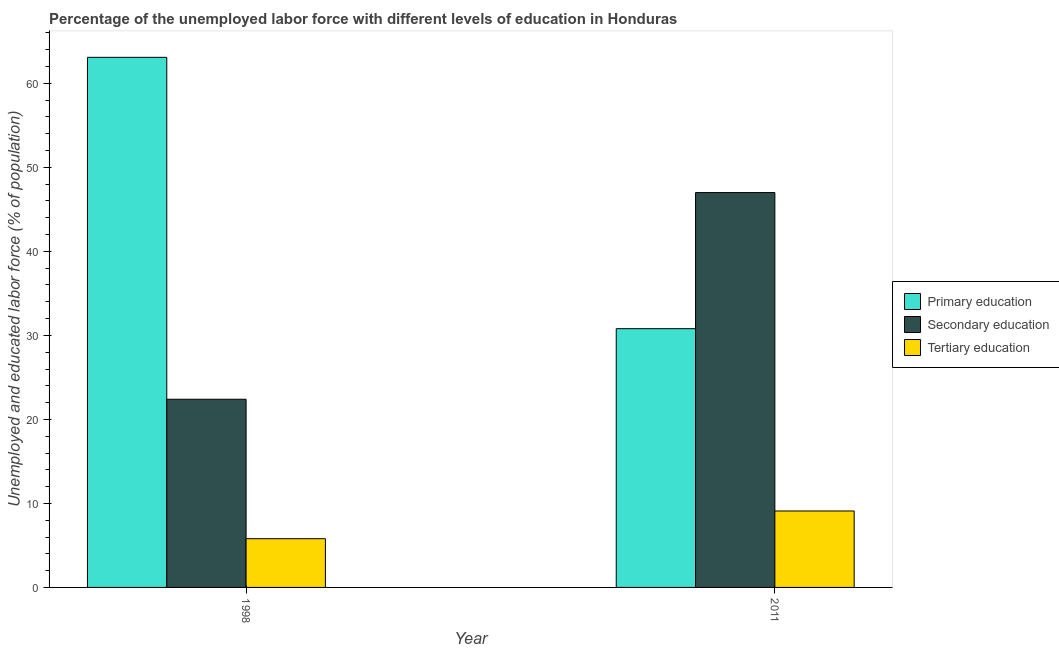How many groups of bars are there?
Your response must be concise. 2. Are the number of bars per tick equal to the number of legend labels?
Provide a succinct answer. Yes. How many bars are there on the 1st tick from the right?
Your answer should be very brief. 3. What is the label of the 1st group of bars from the left?
Your answer should be very brief. 1998. In how many cases, is the number of bars for a given year not equal to the number of legend labels?
Provide a succinct answer. 0. Across all years, what is the maximum percentage of labor force who received primary education?
Provide a succinct answer. 63.1. Across all years, what is the minimum percentage of labor force who received primary education?
Offer a terse response. 30.8. In which year was the percentage of labor force who received secondary education maximum?
Offer a terse response. 2011. What is the total percentage of labor force who received secondary education in the graph?
Give a very brief answer. 69.4. What is the difference between the percentage of labor force who received secondary education in 1998 and that in 2011?
Provide a short and direct response. -24.6. What is the difference between the percentage of labor force who received secondary education in 2011 and the percentage of labor force who received primary education in 1998?
Offer a terse response. 24.6. What is the average percentage of labor force who received secondary education per year?
Keep it short and to the point. 34.7. In how many years, is the percentage of labor force who received primary education greater than 58 %?
Offer a very short reply. 1. What is the ratio of the percentage of labor force who received primary education in 1998 to that in 2011?
Offer a very short reply. 2.05. Is the percentage of labor force who received secondary education in 1998 less than that in 2011?
Your answer should be very brief. Yes. What does the 3rd bar from the left in 1998 represents?
Your answer should be compact. Tertiary education. What does the 1st bar from the right in 1998 represents?
Make the answer very short. Tertiary education. How many bars are there?
Offer a terse response. 6. Are all the bars in the graph horizontal?
Provide a short and direct response. No. What is the difference between two consecutive major ticks on the Y-axis?
Your answer should be compact. 10. Does the graph contain grids?
Give a very brief answer. No. Where does the legend appear in the graph?
Make the answer very short. Center right. How are the legend labels stacked?
Ensure brevity in your answer.  Vertical. What is the title of the graph?
Offer a terse response. Percentage of the unemployed labor force with different levels of education in Honduras. What is the label or title of the X-axis?
Give a very brief answer. Year. What is the label or title of the Y-axis?
Provide a short and direct response. Unemployed and educated labor force (% of population). What is the Unemployed and educated labor force (% of population) in Primary education in 1998?
Ensure brevity in your answer.  63.1. What is the Unemployed and educated labor force (% of population) of Secondary education in 1998?
Give a very brief answer. 22.4. What is the Unemployed and educated labor force (% of population) of Tertiary education in 1998?
Your answer should be very brief. 5.8. What is the Unemployed and educated labor force (% of population) of Primary education in 2011?
Keep it short and to the point. 30.8. What is the Unemployed and educated labor force (% of population) of Tertiary education in 2011?
Ensure brevity in your answer.  9.1. Across all years, what is the maximum Unemployed and educated labor force (% of population) of Primary education?
Offer a very short reply. 63.1. Across all years, what is the maximum Unemployed and educated labor force (% of population) of Tertiary education?
Offer a very short reply. 9.1. Across all years, what is the minimum Unemployed and educated labor force (% of population) in Primary education?
Offer a very short reply. 30.8. Across all years, what is the minimum Unemployed and educated labor force (% of population) in Secondary education?
Provide a succinct answer. 22.4. Across all years, what is the minimum Unemployed and educated labor force (% of population) in Tertiary education?
Give a very brief answer. 5.8. What is the total Unemployed and educated labor force (% of population) in Primary education in the graph?
Keep it short and to the point. 93.9. What is the total Unemployed and educated labor force (% of population) in Secondary education in the graph?
Your response must be concise. 69.4. What is the difference between the Unemployed and educated labor force (% of population) in Primary education in 1998 and that in 2011?
Give a very brief answer. 32.3. What is the difference between the Unemployed and educated labor force (% of population) in Secondary education in 1998 and that in 2011?
Offer a very short reply. -24.6. What is the difference between the Unemployed and educated labor force (% of population) of Primary education in 1998 and the Unemployed and educated labor force (% of population) of Secondary education in 2011?
Ensure brevity in your answer.  16.1. What is the difference between the Unemployed and educated labor force (% of population) in Primary education in 1998 and the Unemployed and educated labor force (% of population) in Tertiary education in 2011?
Offer a terse response. 54. What is the difference between the Unemployed and educated labor force (% of population) in Secondary education in 1998 and the Unemployed and educated labor force (% of population) in Tertiary education in 2011?
Give a very brief answer. 13.3. What is the average Unemployed and educated labor force (% of population) of Primary education per year?
Your answer should be compact. 46.95. What is the average Unemployed and educated labor force (% of population) of Secondary education per year?
Keep it short and to the point. 34.7. What is the average Unemployed and educated labor force (% of population) of Tertiary education per year?
Ensure brevity in your answer.  7.45. In the year 1998, what is the difference between the Unemployed and educated labor force (% of population) of Primary education and Unemployed and educated labor force (% of population) of Secondary education?
Your answer should be compact. 40.7. In the year 1998, what is the difference between the Unemployed and educated labor force (% of population) of Primary education and Unemployed and educated labor force (% of population) of Tertiary education?
Provide a short and direct response. 57.3. In the year 2011, what is the difference between the Unemployed and educated labor force (% of population) in Primary education and Unemployed and educated labor force (% of population) in Secondary education?
Give a very brief answer. -16.2. In the year 2011, what is the difference between the Unemployed and educated labor force (% of population) in Primary education and Unemployed and educated labor force (% of population) in Tertiary education?
Ensure brevity in your answer.  21.7. In the year 2011, what is the difference between the Unemployed and educated labor force (% of population) in Secondary education and Unemployed and educated labor force (% of population) in Tertiary education?
Provide a short and direct response. 37.9. What is the ratio of the Unemployed and educated labor force (% of population) of Primary education in 1998 to that in 2011?
Keep it short and to the point. 2.05. What is the ratio of the Unemployed and educated labor force (% of population) of Secondary education in 1998 to that in 2011?
Your response must be concise. 0.48. What is the ratio of the Unemployed and educated labor force (% of population) in Tertiary education in 1998 to that in 2011?
Make the answer very short. 0.64. What is the difference between the highest and the second highest Unemployed and educated labor force (% of population) of Primary education?
Make the answer very short. 32.3. What is the difference between the highest and the second highest Unemployed and educated labor force (% of population) of Secondary education?
Your answer should be compact. 24.6. What is the difference between the highest and the lowest Unemployed and educated labor force (% of population) in Primary education?
Provide a succinct answer. 32.3. What is the difference between the highest and the lowest Unemployed and educated labor force (% of population) in Secondary education?
Keep it short and to the point. 24.6. 